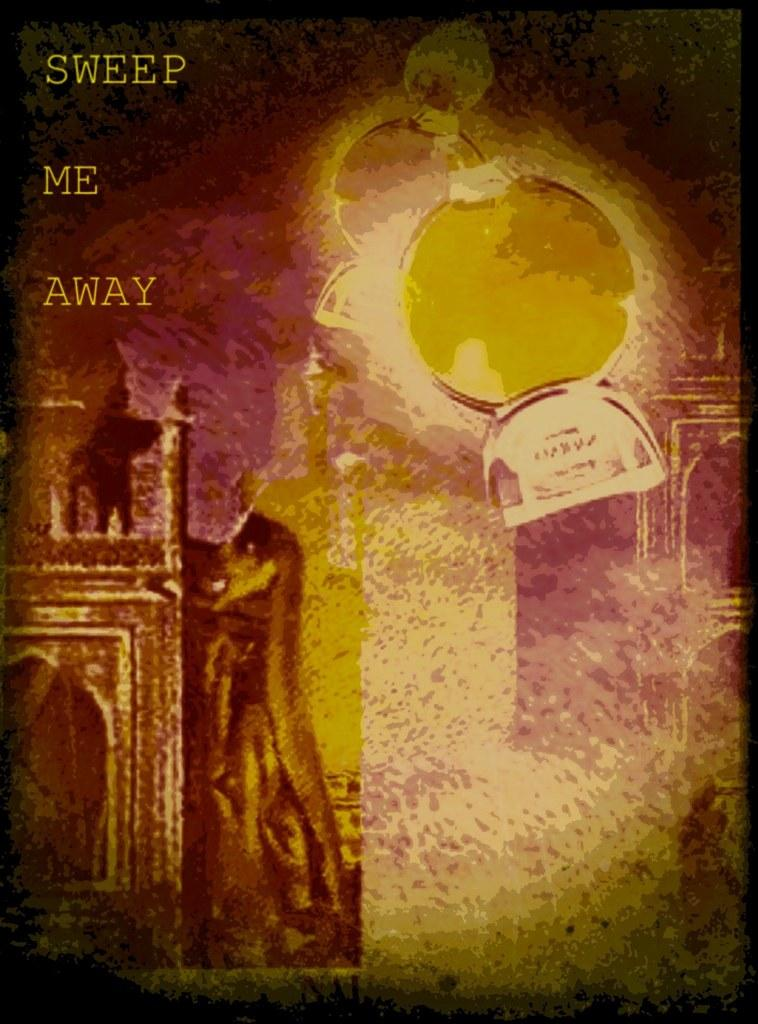<image>
Summarize the visual content of the image. An ad for something with the words "Sweep Me Away" in the top left corner. 